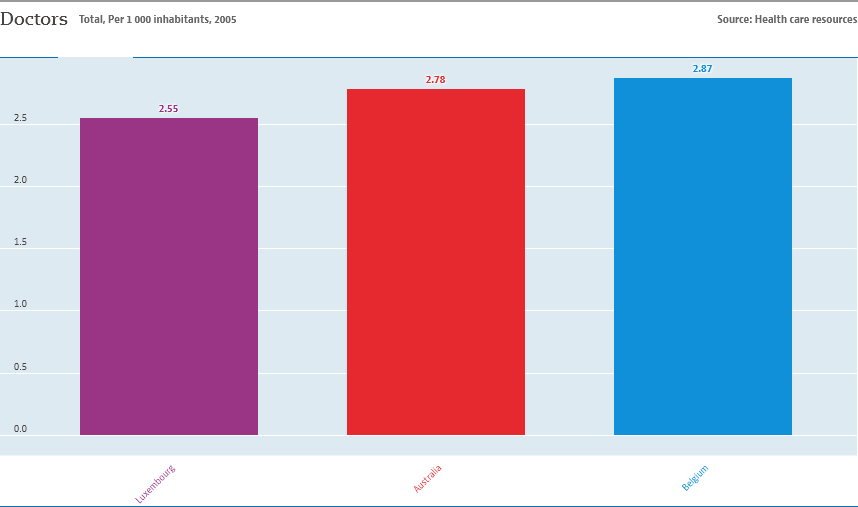Indicate a few pertinent items in this graphic. The number of colors used in the graph is three. The average of Australia and Belgium is not equal to the value of the smallest bar. 